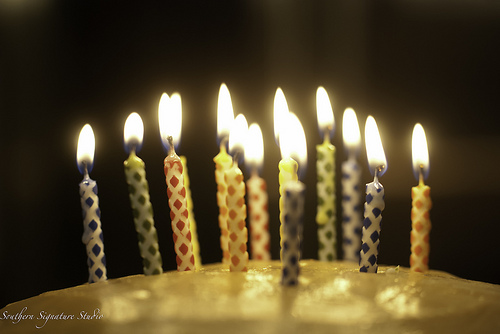<image>
Can you confirm if the flame is next to the candle? No. The flame is not positioned next to the candle. They are located in different areas of the scene. 